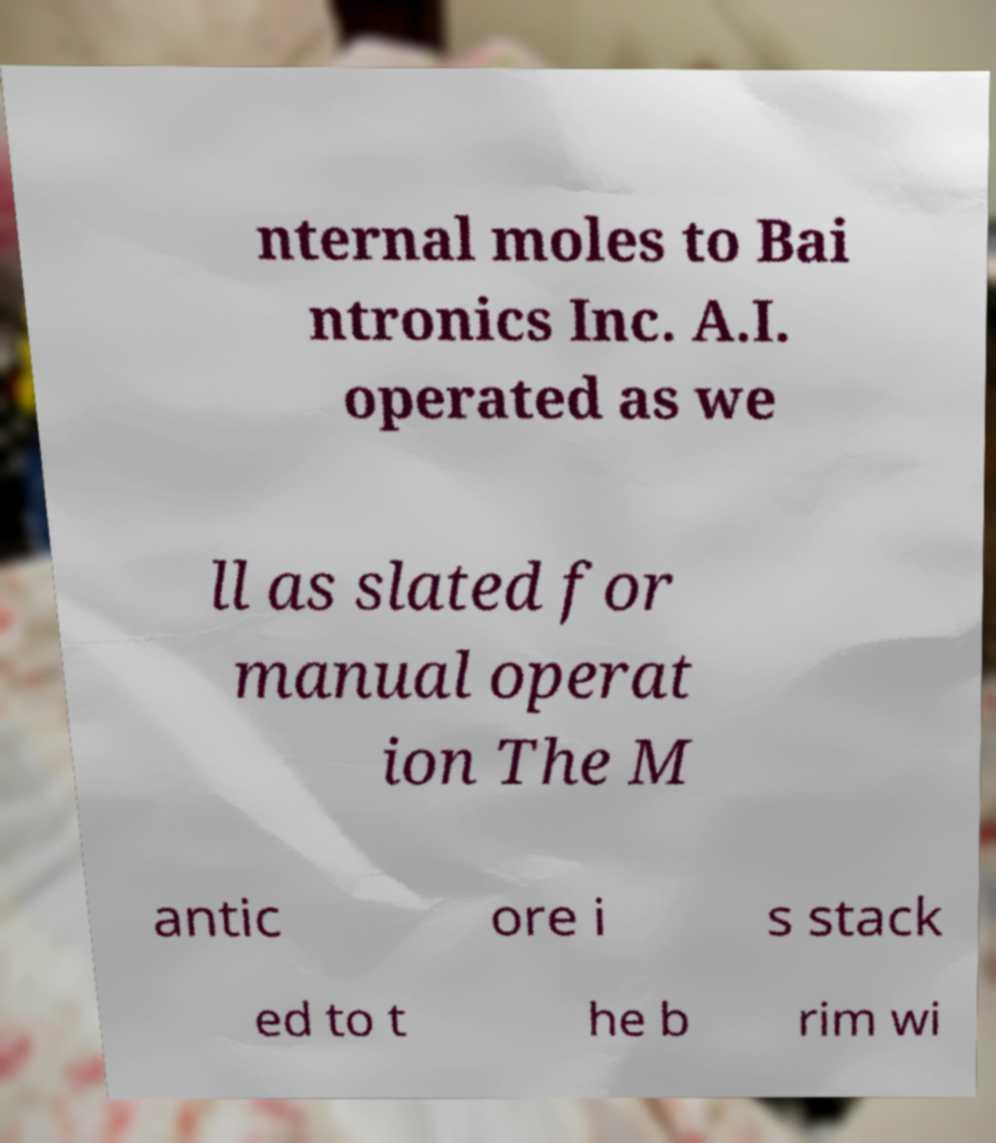For documentation purposes, I need the text within this image transcribed. Could you provide that? nternal moles to Bai ntronics Inc. A.I. operated as we ll as slated for manual operat ion The M antic ore i s stack ed to t he b rim wi 